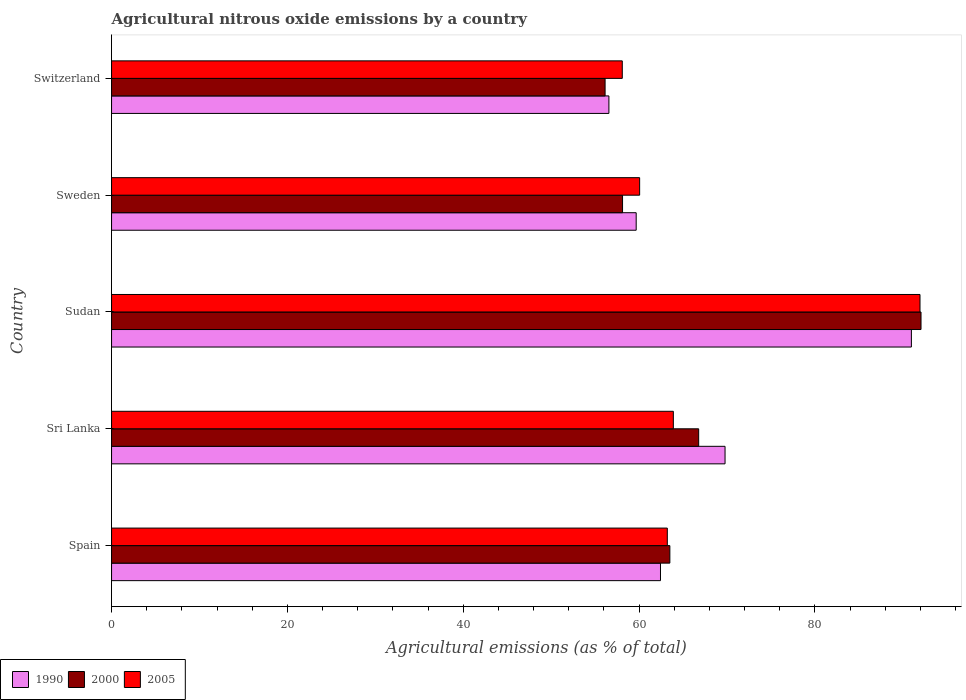How many groups of bars are there?
Give a very brief answer. 5. Are the number of bars on each tick of the Y-axis equal?
Offer a very short reply. Yes. What is the label of the 4th group of bars from the top?
Give a very brief answer. Sri Lanka. What is the amount of agricultural nitrous oxide emitted in 1990 in Spain?
Provide a short and direct response. 62.44. Across all countries, what is the maximum amount of agricultural nitrous oxide emitted in 2000?
Offer a very short reply. 92.07. Across all countries, what is the minimum amount of agricultural nitrous oxide emitted in 1990?
Make the answer very short. 56.57. In which country was the amount of agricultural nitrous oxide emitted in 2005 maximum?
Offer a terse response. Sudan. In which country was the amount of agricultural nitrous oxide emitted in 1990 minimum?
Ensure brevity in your answer.  Switzerland. What is the total amount of agricultural nitrous oxide emitted in 1990 in the graph?
Keep it short and to the point. 339.43. What is the difference between the amount of agricultural nitrous oxide emitted in 1990 in Sri Lanka and that in Sweden?
Keep it short and to the point. 10.11. What is the difference between the amount of agricultural nitrous oxide emitted in 2005 in Sudan and the amount of agricultural nitrous oxide emitted in 1990 in Sweden?
Your answer should be compact. 32.28. What is the average amount of agricultural nitrous oxide emitted in 2000 per country?
Make the answer very short. 67.32. What is the difference between the amount of agricultural nitrous oxide emitted in 2000 and amount of agricultural nitrous oxide emitted in 2005 in Switzerland?
Provide a succinct answer. -1.96. In how many countries, is the amount of agricultural nitrous oxide emitted in 2000 greater than 44 %?
Provide a short and direct response. 5. What is the ratio of the amount of agricultural nitrous oxide emitted in 2005 in Sri Lanka to that in Sweden?
Keep it short and to the point. 1.06. Is the amount of agricultural nitrous oxide emitted in 2000 in Sweden less than that in Switzerland?
Give a very brief answer. No. What is the difference between the highest and the second highest amount of agricultural nitrous oxide emitted in 2000?
Your response must be concise. 25.29. What is the difference between the highest and the lowest amount of agricultural nitrous oxide emitted in 2005?
Provide a succinct answer. 33.86. In how many countries, is the amount of agricultural nitrous oxide emitted in 1990 greater than the average amount of agricultural nitrous oxide emitted in 1990 taken over all countries?
Offer a terse response. 2. What does the 1st bar from the top in Sweden represents?
Make the answer very short. 2005. Are all the bars in the graph horizontal?
Offer a very short reply. Yes. Does the graph contain any zero values?
Offer a terse response. No. Where does the legend appear in the graph?
Offer a very short reply. Bottom left. How many legend labels are there?
Provide a short and direct response. 3. How are the legend labels stacked?
Provide a succinct answer. Horizontal. What is the title of the graph?
Your answer should be compact. Agricultural nitrous oxide emissions by a country. What is the label or title of the X-axis?
Your response must be concise. Agricultural emissions (as % of total). What is the Agricultural emissions (as % of total) of 1990 in Spain?
Provide a short and direct response. 62.44. What is the Agricultural emissions (as % of total) of 2000 in Spain?
Your answer should be very brief. 63.5. What is the Agricultural emissions (as % of total) of 2005 in Spain?
Your response must be concise. 63.21. What is the Agricultural emissions (as % of total) of 1990 in Sri Lanka?
Make the answer very short. 69.78. What is the Agricultural emissions (as % of total) of 2000 in Sri Lanka?
Provide a short and direct response. 66.78. What is the Agricultural emissions (as % of total) in 2005 in Sri Lanka?
Give a very brief answer. 63.9. What is the Agricultural emissions (as % of total) in 1990 in Sudan?
Give a very brief answer. 90.97. What is the Agricultural emissions (as % of total) of 2000 in Sudan?
Offer a terse response. 92.07. What is the Agricultural emissions (as % of total) in 2005 in Sudan?
Offer a terse response. 91.95. What is the Agricultural emissions (as % of total) in 1990 in Sweden?
Keep it short and to the point. 59.67. What is the Agricultural emissions (as % of total) of 2000 in Sweden?
Your answer should be compact. 58.12. What is the Agricultural emissions (as % of total) in 2005 in Sweden?
Make the answer very short. 60.06. What is the Agricultural emissions (as % of total) of 1990 in Switzerland?
Offer a very short reply. 56.57. What is the Agricultural emissions (as % of total) in 2000 in Switzerland?
Give a very brief answer. 56.13. What is the Agricultural emissions (as % of total) in 2005 in Switzerland?
Provide a succinct answer. 58.09. Across all countries, what is the maximum Agricultural emissions (as % of total) in 1990?
Give a very brief answer. 90.97. Across all countries, what is the maximum Agricultural emissions (as % of total) in 2000?
Provide a short and direct response. 92.07. Across all countries, what is the maximum Agricultural emissions (as % of total) of 2005?
Your response must be concise. 91.95. Across all countries, what is the minimum Agricultural emissions (as % of total) of 1990?
Give a very brief answer. 56.57. Across all countries, what is the minimum Agricultural emissions (as % of total) of 2000?
Your answer should be very brief. 56.13. Across all countries, what is the minimum Agricultural emissions (as % of total) in 2005?
Offer a very short reply. 58.09. What is the total Agricultural emissions (as % of total) in 1990 in the graph?
Make the answer very short. 339.43. What is the total Agricultural emissions (as % of total) in 2000 in the graph?
Ensure brevity in your answer.  336.6. What is the total Agricultural emissions (as % of total) in 2005 in the graph?
Provide a short and direct response. 337.22. What is the difference between the Agricultural emissions (as % of total) in 1990 in Spain and that in Sri Lanka?
Keep it short and to the point. -7.34. What is the difference between the Agricultural emissions (as % of total) of 2000 in Spain and that in Sri Lanka?
Make the answer very short. -3.28. What is the difference between the Agricultural emissions (as % of total) in 2005 in Spain and that in Sri Lanka?
Make the answer very short. -0.69. What is the difference between the Agricultural emissions (as % of total) in 1990 in Spain and that in Sudan?
Make the answer very short. -28.54. What is the difference between the Agricultural emissions (as % of total) in 2000 in Spain and that in Sudan?
Ensure brevity in your answer.  -28.57. What is the difference between the Agricultural emissions (as % of total) in 2005 in Spain and that in Sudan?
Your answer should be very brief. -28.74. What is the difference between the Agricultural emissions (as % of total) of 1990 in Spain and that in Sweden?
Provide a succinct answer. 2.76. What is the difference between the Agricultural emissions (as % of total) of 2000 in Spain and that in Sweden?
Keep it short and to the point. 5.38. What is the difference between the Agricultural emissions (as % of total) of 2005 in Spain and that in Sweden?
Give a very brief answer. 3.15. What is the difference between the Agricultural emissions (as % of total) of 1990 in Spain and that in Switzerland?
Your answer should be compact. 5.87. What is the difference between the Agricultural emissions (as % of total) in 2000 in Spain and that in Switzerland?
Your answer should be compact. 7.37. What is the difference between the Agricultural emissions (as % of total) of 2005 in Spain and that in Switzerland?
Keep it short and to the point. 5.12. What is the difference between the Agricultural emissions (as % of total) in 1990 in Sri Lanka and that in Sudan?
Your response must be concise. -21.19. What is the difference between the Agricultural emissions (as % of total) of 2000 in Sri Lanka and that in Sudan?
Provide a short and direct response. -25.29. What is the difference between the Agricultural emissions (as % of total) in 2005 in Sri Lanka and that in Sudan?
Your answer should be very brief. -28.05. What is the difference between the Agricultural emissions (as % of total) in 1990 in Sri Lanka and that in Sweden?
Your response must be concise. 10.11. What is the difference between the Agricultural emissions (as % of total) in 2000 in Sri Lanka and that in Sweden?
Make the answer very short. 8.66. What is the difference between the Agricultural emissions (as % of total) of 2005 in Sri Lanka and that in Sweden?
Keep it short and to the point. 3.83. What is the difference between the Agricultural emissions (as % of total) of 1990 in Sri Lanka and that in Switzerland?
Your response must be concise. 13.21. What is the difference between the Agricultural emissions (as % of total) in 2000 in Sri Lanka and that in Switzerland?
Make the answer very short. 10.64. What is the difference between the Agricultural emissions (as % of total) in 2005 in Sri Lanka and that in Switzerland?
Give a very brief answer. 5.81. What is the difference between the Agricultural emissions (as % of total) of 1990 in Sudan and that in Sweden?
Keep it short and to the point. 31.3. What is the difference between the Agricultural emissions (as % of total) in 2000 in Sudan and that in Sweden?
Provide a short and direct response. 33.95. What is the difference between the Agricultural emissions (as % of total) in 2005 in Sudan and that in Sweden?
Your response must be concise. 31.89. What is the difference between the Agricultural emissions (as % of total) of 1990 in Sudan and that in Switzerland?
Offer a very short reply. 34.4. What is the difference between the Agricultural emissions (as % of total) of 2000 in Sudan and that in Switzerland?
Your answer should be compact. 35.93. What is the difference between the Agricultural emissions (as % of total) in 2005 in Sudan and that in Switzerland?
Offer a very short reply. 33.86. What is the difference between the Agricultural emissions (as % of total) of 1990 in Sweden and that in Switzerland?
Give a very brief answer. 3.1. What is the difference between the Agricultural emissions (as % of total) in 2000 in Sweden and that in Switzerland?
Give a very brief answer. 1.99. What is the difference between the Agricultural emissions (as % of total) of 2005 in Sweden and that in Switzerland?
Provide a succinct answer. 1.97. What is the difference between the Agricultural emissions (as % of total) of 1990 in Spain and the Agricultural emissions (as % of total) of 2000 in Sri Lanka?
Offer a very short reply. -4.34. What is the difference between the Agricultural emissions (as % of total) in 1990 in Spain and the Agricultural emissions (as % of total) in 2005 in Sri Lanka?
Your response must be concise. -1.46. What is the difference between the Agricultural emissions (as % of total) in 2000 in Spain and the Agricultural emissions (as % of total) in 2005 in Sri Lanka?
Provide a short and direct response. -0.4. What is the difference between the Agricultural emissions (as % of total) of 1990 in Spain and the Agricultural emissions (as % of total) of 2000 in Sudan?
Make the answer very short. -29.63. What is the difference between the Agricultural emissions (as % of total) in 1990 in Spain and the Agricultural emissions (as % of total) in 2005 in Sudan?
Your response must be concise. -29.52. What is the difference between the Agricultural emissions (as % of total) in 2000 in Spain and the Agricultural emissions (as % of total) in 2005 in Sudan?
Keep it short and to the point. -28.45. What is the difference between the Agricultural emissions (as % of total) in 1990 in Spain and the Agricultural emissions (as % of total) in 2000 in Sweden?
Your answer should be very brief. 4.32. What is the difference between the Agricultural emissions (as % of total) of 1990 in Spain and the Agricultural emissions (as % of total) of 2005 in Sweden?
Make the answer very short. 2.37. What is the difference between the Agricultural emissions (as % of total) of 2000 in Spain and the Agricultural emissions (as % of total) of 2005 in Sweden?
Your response must be concise. 3.44. What is the difference between the Agricultural emissions (as % of total) of 1990 in Spain and the Agricultural emissions (as % of total) of 2000 in Switzerland?
Keep it short and to the point. 6.3. What is the difference between the Agricultural emissions (as % of total) in 1990 in Spain and the Agricultural emissions (as % of total) in 2005 in Switzerland?
Make the answer very short. 4.35. What is the difference between the Agricultural emissions (as % of total) of 2000 in Spain and the Agricultural emissions (as % of total) of 2005 in Switzerland?
Your answer should be compact. 5.41. What is the difference between the Agricultural emissions (as % of total) of 1990 in Sri Lanka and the Agricultural emissions (as % of total) of 2000 in Sudan?
Offer a very short reply. -22.29. What is the difference between the Agricultural emissions (as % of total) in 1990 in Sri Lanka and the Agricultural emissions (as % of total) in 2005 in Sudan?
Keep it short and to the point. -22.17. What is the difference between the Agricultural emissions (as % of total) of 2000 in Sri Lanka and the Agricultural emissions (as % of total) of 2005 in Sudan?
Give a very brief answer. -25.17. What is the difference between the Agricultural emissions (as % of total) in 1990 in Sri Lanka and the Agricultural emissions (as % of total) in 2000 in Sweden?
Keep it short and to the point. 11.66. What is the difference between the Agricultural emissions (as % of total) in 1990 in Sri Lanka and the Agricultural emissions (as % of total) in 2005 in Sweden?
Your response must be concise. 9.72. What is the difference between the Agricultural emissions (as % of total) in 2000 in Sri Lanka and the Agricultural emissions (as % of total) in 2005 in Sweden?
Provide a short and direct response. 6.71. What is the difference between the Agricultural emissions (as % of total) of 1990 in Sri Lanka and the Agricultural emissions (as % of total) of 2000 in Switzerland?
Your answer should be very brief. 13.64. What is the difference between the Agricultural emissions (as % of total) in 1990 in Sri Lanka and the Agricultural emissions (as % of total) in 2005 in Switzerland?
Your answer should be very brief. 11.69. What is the difference between the Agricultural emissions (as % of total) in 2000 in Sri Lanka and the Agricultural emissions (as % of total) in 2005 in Switzerland?
Keep it short and to the point. 8.69. What is the difference between the Agricultural emissions (as % of total) of 1990 in Sudan and the Agricultural emissions (as % of total) of 2000 in Sweden?
Your answer should be very brief. 32.85. What is the difference between the Agricultural emissions (as % of total) of 1990 in Sudan and the Agricultural emissions (as % of total) of 2005 in Sweden?
Provide a succinct answer. 30.91. What is the difference between the Agricultural emissions (as % of total) of 2000 in Sudan and the Agricultural emissions (as % of total) of 2005 in Sweden?
Ensure brevity in your answer.  32. What is the difference between the Agricultural emissions (as % of total) of 1990 in Sudan and the Agricultural emissions (as % of total) of 2000 in Switzerland?
Offer a very short reply. 34.84. What is the difference between the Agricultural emissions (as % of total) of 1990 in Sudan and the Agricultural emissions (as % of total) of 2005 in Switzerland?
Give a very brief answer. 32.88. What is the difference between the Agricultural emissions (as % of total) of 2000 in Sudan and the Agricultural emissions (as % of total) of 2005 in Switzerland?
Offer a terse response. 33.98. What is the difference between the Agricultural emissions (as % of total) of 1990 in Sweden and the Agricultural emissions (as % of total) of 2000 in Switzerland?
Offer a very short reply. 3.54. What is the difference between the Agricultural emissions (as % of total) in 1990 in Sweden and the Agricultural emissions (as % of total) in 2005 in Switzerland?
Make the answer very short. 1.58. What is the difference between the Agricultural emissions (as % of total) of 2000 in Sweden and the Agricultural emissions (as % of total) of 2005 in Switzerland?
Your answer should be compact. 0.03. What is the average Agricultural emissions (as % of total) in 1990 per country?
Make the answer very short. 67.89. What is the average Agricultural emissions (as % of total) in 2000 per country?
Your answer should be compact. 67.32. What is the average Agricultural emissions (as % of total) in 2005 per country?
Offer a terse response. 67.44. What is the difference between the Agricultural emissions (as % of total) in 1990 and Agricultural emissions (as % of total) in 2000 in Spain?
Your response must be concise. -1.07. What is the difference between the Agricultural emissions (as % of total) in 1990 and Agricultural emissions (as % of total) in 2005 in Spain?
Keep it short and to the point. -0.78. What is the difference between the Agricultural emissions (as % of total) in 2000 and Agricultural emissions (as % of total) in 2005 in Spain?
Provide a short and direct response. 0.29. What is the difference between the Agricultural emissions (as % of total) of 1990 and Agricultural emissions (as % of total) of 2000 in Sri Lanka?
Provide a short and direct response. 3. What is the difference between the Agricultural emissions (as % of total) in 1990 and Agricultural emissions (as % of total) in 2005 in Sri Lanka?
Ensure brevity in your answer.  5.88. What is the difference between the Agricultural emissions (as % of total) of 2000 and Agricultural emissions (as % of total) of 2005 in Sri Lanka?
Give a very brief answer. 2.88. What is the difference between the Agricultural emissions (as % of total) of 1990 and Agricultural emissions (as % of total) of 2000 in Sudan?
Your answer should be compact. -1.1. What is the difference between the Agricultural emissions (as % of total) of 1990 and Agricultural emissions (as % of total) of 2005 in Sudan?
Provide a succinct answer. -0.98. What is the difference between the Agricultural emissions (as % of total) in 2000 and Agricultural emissions (as % of total) in 2005 in Sudan?
Offer a terse response. 0.12. What is the difference between the Agricultural emissions (as % of total) in 1990 and Agricultural emissions (as % of total) in 2000 in Sweden?
Make the answer very short. 1.55. What is the difference between the Agricultural emissions (as % of total) of 1990 and Agricultural emissions (as % of total) of 2005 in Sweden?
Ensure brevity in your answer.  -0.39. What is the difference between the Agricultural emissions (as % of total) of 2000 and Agricultural emissions (as % of total) of 2005 in Sweden?
Your answer should be very brief. -1.94. What is the difference between the Agricultural emissions (as % of total) in 1990 and Agricultural emissions (as % of total) in 2000 in Switzerland?
Provide a short and direct response. 0.44. What is the difference between the Agricultural emissions (as % of total) of 1990 and Agricultural emissions (as % of total) of 2005 in Switzerland?
Keep it short and to the point. -1.52. What is the difference between the Agricultural emissions (as % of total) in 2000 and Agricultural emissions (as % of total) in 2005 in Switzerland?
Your answer should be compact. -1.96. What is the ratio of the Agricultural emissions (as % of total) in 1990 in Spain to that in Sri Lanka?
Provide a short and direct response. 0.89. What is the ratio of the Agricultural emissions (as % of total) of 2000 in Spain to that in Sri Lanka?
Your answer should be compact. 0.95. What is the ratio of the Agricultural emissions (as % of total) of 2005 in Spain to that in Sri Lanka?
Provide a succinct answer. 0.99. What is the ratio of the Agricultural emissions (as % of total) in 1990 in Spain to that in Sudan?
Keep it short and to the point. 0.69. What is the ratio of the Agricultural emissions (as % of total) in 2000 in Spain to that in Sudan?
Offer a very short reply. 0.69. What is the ratio of the Agricultural emissions (as % of total) of 2005 in Spain to that in Sudan?
Offer a terse response. 0.69. What is the ratio of the Agricultural emissions (as % of total) of 1990 in Spain to that in Sweden?
Keep it short and to the point. 1.05. What is the ratio of the Agricultural emissions (as % of total) of 2000 in Spain to that in Sweden?
Your answer should be compact. 1.09. What is the ratio of the Agricultural emissions (as % of total) in 2005 in Spain to that in Sweden?
Your answer should be very brief. 1.05. What is the ratio of the Agricultural emissions (as % of total) in 1990 in Spain to that in Switzerland?
Provide a short and direct response. 1.1. What is the ratio of the Agricultural emissions (as % of total) in 2000 in Spain to that in Switzerland?
Provide a succinct answer. 1.13. What is the ratio of the Agricultural emissions (as % of total) of 2005 in Spain to that in Switzerland?
Ensure brevity in your answer.  1.09. What is the ratio of the Agricultural emissions (as % of total) in 1990 in Sri Lanka to that in Sudan?
Your answer should be very brief. 0.77. What is the ratio of the Agricultural emissions (as % of total) in 2000 in Sri Lanka to that in Sudan?
Ensure brevity in your answer.  0.73. What is the ratio of the Agricultural emissions (as % of total) in 2005 in Sri Lanka to that in Sudan?
Give a very brief answer. 0.69. What is the ratio of the Agricultural emissions (as % of total) in 1990 in Sri Lanka to that in Sweden?
Your answer should be compact. 1.17. What is the ratio of the Agricultural emissions (as % of total) of 2000 in Sri Lanka to that in Sweden?
Your answer should be compact. 1.15. What is the ratio of the Agricultural emissions (as % of total) of 2005 in Sri Lanka to that in Sweden?
Offer a terse response. 1.06. What is the ratio of the Agricultural emissions (as % of total) in 1990 in Sri Lanka to that in Switzerland?
Provide a short and direct response. 1.23. What is the ratio of the Agricultural emissions (as % of total) in 2000 in Sri Lanka to that in Switzerland?
Your answer should be very brief. 1.19. What is the ratio of the Agricultural emissions (as % of total) of 2005 in Sri Lanka to that in Switzerland?
Offer a very short reply. 1.1. What is the ratio of the Agricultural emissions (as % of total) in 1990 in Sudan to that in Sweden?
Keep it short and to the point. 1.52. What is the ratio of the Agricultural emissions (as % of total) in 2000 in Sudan to that in Sweden?
Offer a terse response. 1.58. What is the ratio of the Agricultural emissions (as % of total) in 2005 in Sudan to that in Sweden?
Your response must be concise. 1.53. What is the ratio of the Agricultural emissions (as % of total) in 1990 in Sudan to that in Switzerland?
Provide a succinct answer. 1.61. What is the ratio of the Agricultural emissions (as % of total) of 2000 in Sudan to that in Switzerland?
Make the answer very short. 1.64. What is the ratio of the Agricultural emissions (as % of total) of 2005 in Sudan to that in Switzerland?
Keep it short and to the point. 1.58. What is the ratio of the Agricultural emissions (as % of total) in 1990 in Sweden to that in Switzerland?
Your response must be concise. 1.05. What is the ratio of the Agricultural emissions (as % of total) of 2000 in Sweden to that in Switzerland?
Keep it short and to the point. 1.04. What is the ratio of the Agricultural emissions (as % of total) of 2005 in Sweden to that in Switzerland?
Provide a short and direct response. 1.03. What is the difference between the highest and the second highest Agricultural emissions (as % of total) in 1990?
Provide a succinct answer. 21.19. What is the difference between the highest and the second highest Agricultural emissions (as % of total) in 2000?
Offer a terse response. 25.29. What is the difference between the highest and the second highest Agricultural emissions (as % of total) in 2005?
Give a very brief answer. 28.05. What is the difference between the highest and the lowest Agricultural emissions (as % of total) in 1990?
Ensure brevity in your answer.  34.4. What is the difference between the highest and the lowest Agricultural emissions (as % of total) of 2000?
Your answer should be compact. 35.93. What is the difference between the highest and the lowest Agricultural emissions (as % of total) in 2005?
Your answer should be compact. 33.86. 